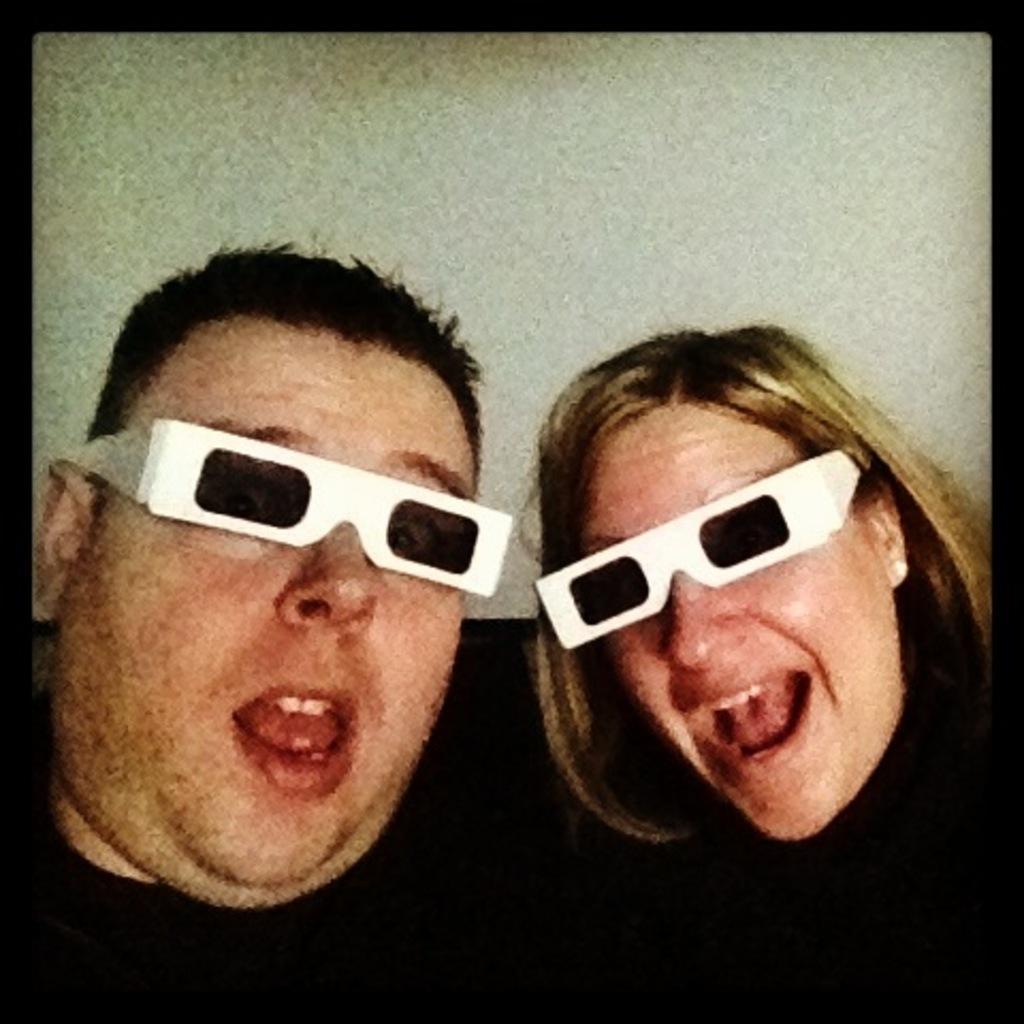Could you give a brief overview of what you see in this image? In this picture, there is a man and a woman wearing black clothes and goggles. 